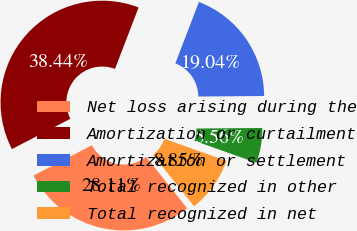<chart> <loc_0><loc_0><loc_500><loc_500><pie_chart><fcel>Net loss arising during the<fcel>Amortization or curtailment<fcel>Amortization or settlement<fcel>Total recognized in other<fcel>Total recognized in net<nl><fcel>28.11%<fcel>38.44%<fcel>19.04%<fcel>5.56%<fcel>8.85%<nl></chart> 